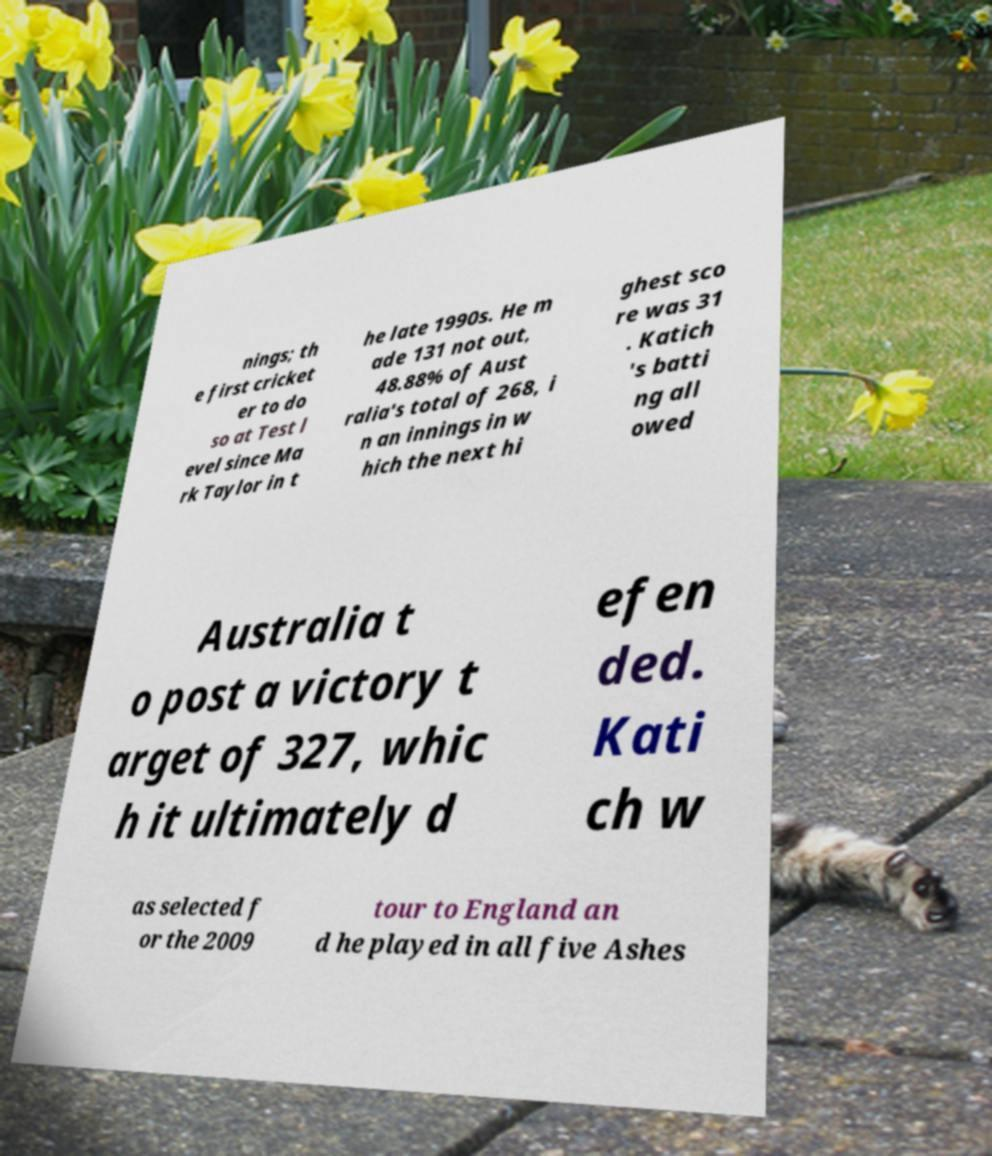Please identify and transcribe the text found in this image. nings; th e first cricket er to do so at Test l evel since Ma rk Taylor in t he late 1990s. He m ade 131 not out, 48.88% of Aust ralia's total of 268, i n an innings in w hich the next hi ghest sco re was 31 . Katich 's batti ng all owed Australia t o post a victory t arget of 327, whic h it ultimately d efen ded. Kati ch w as selected f or the 2009 tour to England an d he played in all five Ashes 